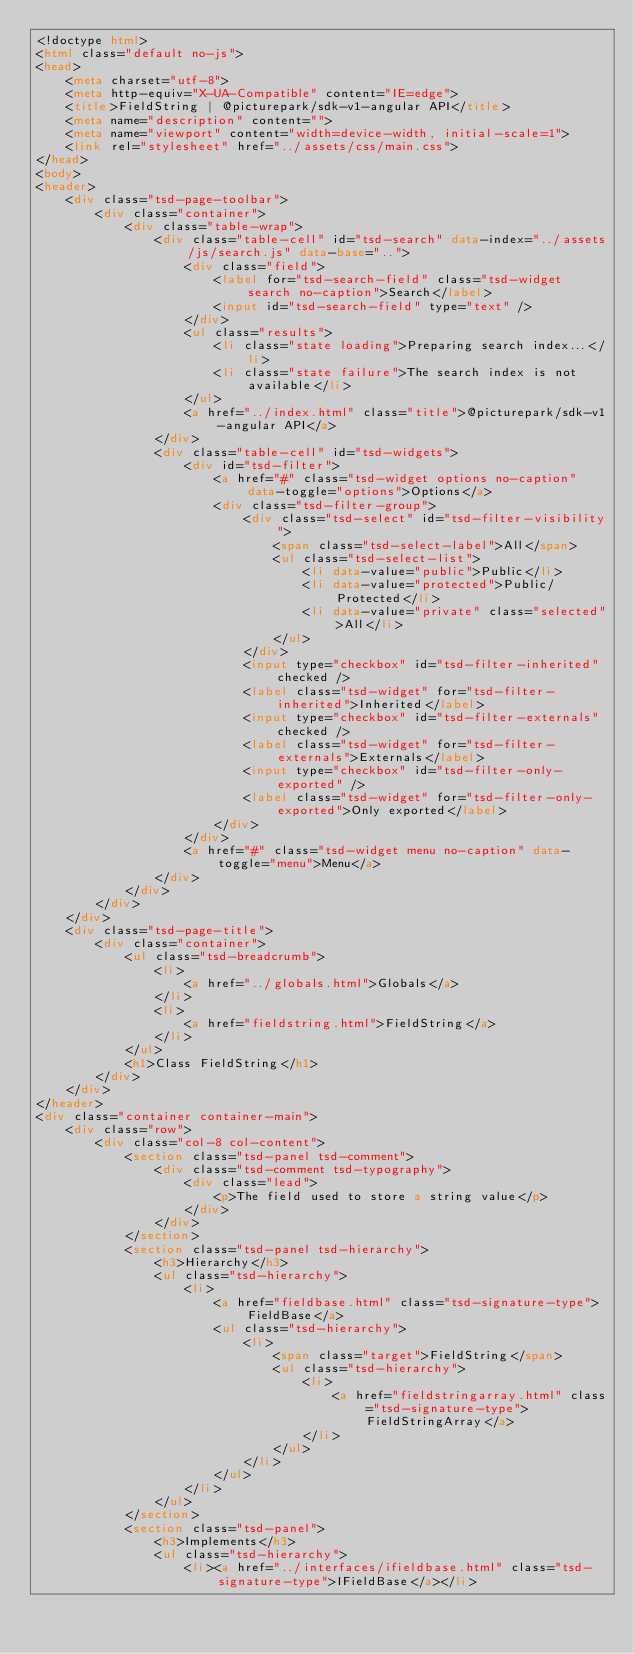Convert code to text. <code><loc_0><loc_0><loc_500><loc_500><_HTML_><!doctype html>
<html class="default no-js">
<head>
	<meta charset="utf-8">
	<meta http-equiv="X-UA-Compatible" content="IE=edge">
	<title>FieldString | @picturepark/sdk-v1-angular API</title>
	<meta name="description" content="">
	<meta name="viewport" content="width=device-width, initial-scale=1">
	<link rel="stylesheet" href="../assets/css/main.css">
</head>
<body>
<header>
	<div class="tsd-page-toolbar">
		<div class="container">
			<div class="table-wrap">
				<div class="table-cell" id="tsd-search" data-index="../assets/js/search.js" data-base="..">
					<div class="field">
						<label for="tsd-search-field" class="tsd-widget search no-caption">Search</label>
						<input id="tsd-search-field" type="text" />
					</div>
					<ul class="results">
						<li class="state loading">Preparing search index...</li>
						<li class="state failure">The search index is not available</li>
					</ul>
					<a href="../index.html" class="title">@picturepark/sdk-v1-angular API</a>
				</div>
				<div class="table-cell" id="tsd-widgets">
					<div id="tsd-filter">
						<a href="#" class="tsd-widget options no-caption" data-toggle="options">Options</a>
						<div class="tsd-filter-group">
							<div class="tsd-select" id="tsd-filter-visibility">
								<span class="tsd-select-label">All</span>
								<ul class="tsd-select-list">
									<li data-value="public">Public</li>
									<li data-value="protected">Public/Protected</li>
									<li data-value="private" class="selected">All</li>
								</ul>
							</div>
							<input type="checkbox" id="tsd-filter-inherited" checked />
							<label class="tsd-widget" for="tsd-filter-inherited">Inherited</label>
							<input type="checkbox" id="tsd-filter-externals" checked />
							<label class="tsd-widget" for="tsd-filter-externals">Externals</label>
							<input type="checkbox" id="tsd-filter-only-exported" />
							<label class="tsd-widget" for="tsd-filter-only-exported">Only exported</label>
						</div>
					</div>
					<a href="#" class="tsd-widget menu no-caption" data-toggle="menu">Menu</a>
				</div>
			</div>
		</div>
	</div>
	<div class="tsd-page-title">
		<div class="container">
			<ul class="tsd-breadcrumb">
				<li>
					<a href="../globals.html">Globals</a>
				</li>
				<li>
					<a href="fieldstring.html">FieldString</a>
				</li>
			</ul>
			<h1>Class FieldString</h1>
		</div>
	</div>
</header>
<div class="container container-main">
	<div class="row">
		<div class="col-8 col-content">
			<section class="tsd-panel tsd-comment">
				<div class="tsd-comment tsd-typography">
					<div class="lead">
						<p>The field used to store a string value</p>
					</div>
				</div>
			</section>
			<section class="tsd-panel tsd-hierarchy">
				<h3>Hierarchy</h3>
				<ul class="tsd-hierarchy">
					<li>
						<a href="fieldbase.html" class="tsd-signature-type">FieldBase</a>
						<ul class="tsd-hierarchy">
							<li>
								<span class="target">FieldString</span>
								<ul class="tsd-hierarchy">
									<li>
										<a href="fieldstringarray.html" class="tsd-signature-type">FieldStringArray</a>
									</li>
								</ul>
							</li>
						</ul>
					</li>
				</ul>
			</section>
			<section class="tsd-panel">
				<h3>Implements</h3>
				<ul class="tsd-hierarchy">
					<li><a href="../interfaces/ifieldbase.html" class="tsd-signature-type">IFieldBase</a></li></code> 